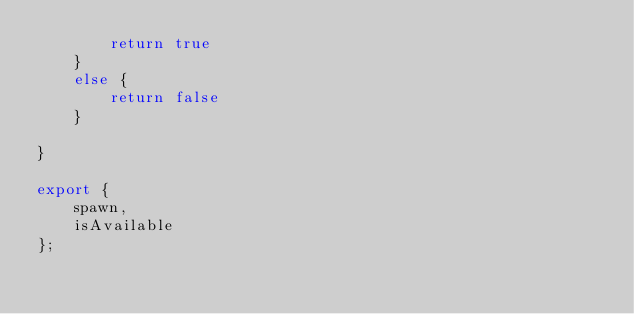Convert code to text. <code><loc_0><loc_0><loc_500><loc_500><_TypeScript_>        return true
    }
    else {
        return false
    }

}

export {
    spawn,
    isAvailable
};
</code> 